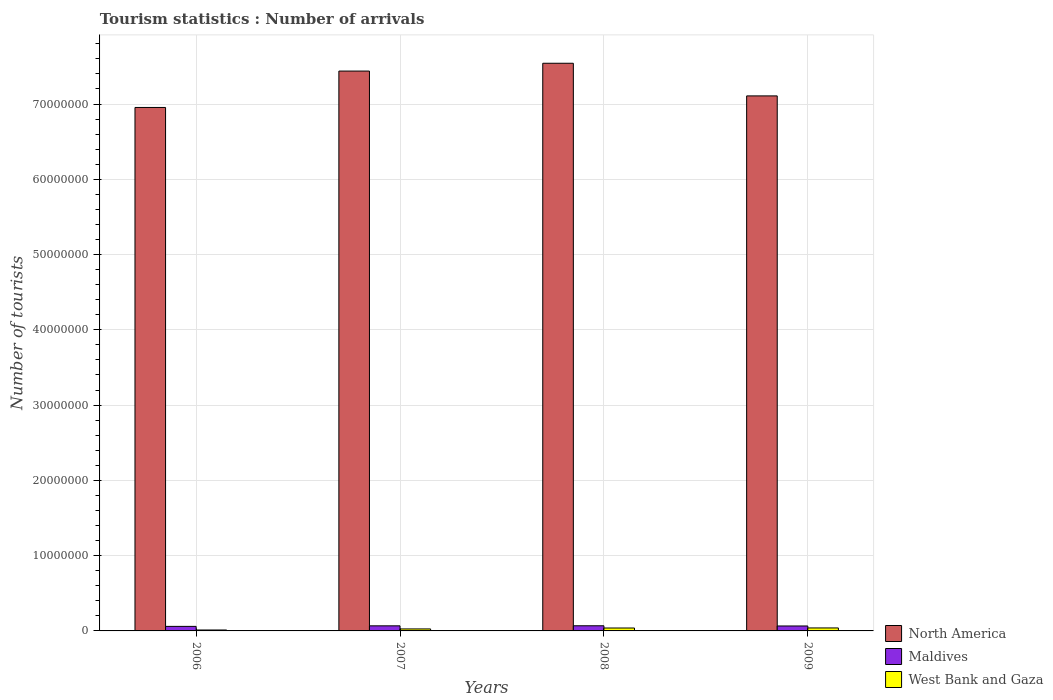How many different coloured bars are there?
Your answer should be compact. 3. How many groups of bars are there?
Provide a succinct answer. 4. Are the number of bars on each tick of the X-axis equal?
Offer a very short reply. Yes. How many bars are there on the 1st tick from the right?
Provide a short and direct response. 3. What is the label of the 3rd group of bars from the left?
Your response must be concise. 2008. What is the number of tourist arrivals in Maldives in 2008?
Provide a short and direct response. 6.83e+05. Across all years, what is the maximum number of tourist arrivals in Maldives?
Provide a succinct answer. 6.83e+05. Across all years, what is the minimum number of tourist arrivals in West Bank and Gaza?
Provide a short and direct response. 1.23e+05. In which year was the number of tourist arrivals in North America minimum?
Make the answer very short. 2006. What is the total number of tourist arrivals in West Bank and Gaza in the graph?
Your response must be concise. 1.17e+06. What is the difference between the number of tourist arrivals in Maldives in 2007 and that in 2008?
Provide a short and direct response. -7000. What is the difference between the number of tourist arrivals in North America in 2008 and the number of tourist arrivals in Maldives in 2009?
Your answer should be compact. 7.48e+07. What is the average number of tourist arrivals in Maldives per year?
Provide a short and direct response. 6.54e+05. In the year 2008, what is the difference between the number of tourist arrivals in Maldives and number of tourist arrivals in West Bank and Gaza?
Offer a terse response. 2.96e+05. What is the ratio of the number of tourist arrivals in North America in 2007 to that in 2009?
Offer a terse response. 1.05. What is the difference between the highest and the second highest number of tourist arrivals in Maldives?
Your response must be concise. 7000. What is the difference between the highest and the lowest number of tourist arrivals in West Bank and Gaza?
Make the answer very short. 2.73e+05. Is the sum of the number of tourist arrivals in West Bank and Gaza in 2006 and 2007 greater than the maximum number of tourist arrivals in North America across all years?
Provide a short and direct response. No. What does the 1st bar from the left in 2008 represents?
Provide a succinct answer. North America. What does the 2nd bar from the right in 2007 represents?
Offer a terse response. Maldives. How many bars are there?
Give a very brief answer. 12. Are all the bars in the graph horizontal?
Offer a terse response. No. How many years are there in the graph?
Offer a very short reply. 4. What is the difference between two consecutive major ticks on the Y-axis?
Provide a short and direct response. 1.00e+07. Where does the legend appear in the graph?
Provide a succinct answer. Bottom right. How many legend labels are there?
Ensure brevity in your answer.  3. What is the title of the graph?
Make the answer very short. Tourism statistics : Number of arrivals. What is the label or title of the X-axis?
Your response must be concise. Years. What is the label or title of the Y-axis?
Ensure brevity in your answer.  Number of tourists. What is the Number of tourists of North America in 2006?
Ensure brevity in your answer.  6.95e+07. What is the Number of tourists in Maldives in 2006?
Make the answer very short. 6.02e+05. What is the Number of tourists in West Bank and Gaza in 2006?
Keep it short and to the point. 1.23e+05. What is the Number of tourists of North America in 2007?
Provide a short and direct response. 7.44e+07. What is the Number of tourists in Maldives in 2007?
Your answer should be very brief. 6.76e+05. What is the Number of tourists of West Bank and Gaza in 2007?
Ensure brevity in your answer.  2.64e+05. What is the Number of tourists of North America in 2008?
Your response must be concise. 7.54e+07. What is the Number of tourists in Maldives in 2008?
Offer a terse response. 6.83e+05. What is the Number of tourists of West Bank and Gaza in 2008?
Give a very brief answer. 3.87e+05. What is the Number of tourists in North America in 2009?
Give a very brief answer. 7.11e+07. What is the Number of tourists in Maldives in 2009?
Your response must be concise. 6.56e+05. What is the Number of tourists in West Bank and Gaza in 2009?
Provide a short and direct response. 3.96e+05. Across all years, what is the maximum Number of tourists in North America?
Provide a short and direct response. 7.54e+07. Across all years, what is the maximum Number of tourists of Maldives?
Offer a very short reply. 6.83e+05. Across all years, what is the maximum Number of tourists in West Bank and Gaza?
Your answer should be compact. 3.96e+05. Across all years, what is the minimum Number of tourists of North America?
Provide a succinct answer. 6.95e+07. Across all years, what is the minimum Number of tourists of Maldives?
Keep it short and to the point. 6.02e+05. Across all years, what is the minimum Number of tourists in West Bank and Gaza?
Keep it short and to the point. 1.23e+05. What is the total Number of tourists of North America in the graph?
Keep it short and to the point. 2.90e+08. What is the total Number of tourists in Maldives in the graph?
Keep it short and to the point. 2.62e+06. What is the total Number of tourists of West Bank and Gaza in the graph?
Ensure brevity in your answer.  1.17e+06. What is the difference between the Number of tourists of North America in 2006 and that in 2007?
Provide a succinct answer. -4.84e+06. What is the difference between the Number of tourists of Maldives in 2006 and that in 2007?
Offer a very short reply. -7.40e+04. What is the difference between the Number of tourists of West Bank and Gaza in 2006 and that in 2007?
Make the answer very short. -1.41e+05. What is the difference between the Number of tourists of North America in 2006 and that in 2008?
Keep it short and to the point. -5.87e+06. What is the difference between the Number of tourists of Maldives in 2006 and that in 2008?
Keep it short and to the point. -8.10e+04. What is the difference between the Number of tourists of West Bank and Gaza in 2006 and that in 2008?
Ensure brevity in your answer.  -2.64e+05. What is the difference between the Number of tourists of North America in 2006 and that in 2009?
Offer a terse response. -1.54e+06. What is the difference between the Number of tourists in Maldives in 2006 and that in 2009?
Offer a terse response. -5.40e+04. What is the difference between the Number of tourists in West Bank and Gaza in 2006 and that in 2009?
Offer a very short reply. -2.73e+05. What is the difference between the Number of tourists in North America in 2007 and that in 2008?
Offer a terse response. -1.04e+06. What is the difference between the Number of tourists in Maldives in 2007 and that in 2008?
Your answer should be very brief. -7000. What is the difference between the Number of tourists of West Bank and Gaza in 2007 and that in 2008?
Keep it short and to the point. -1.23e+05. What is the difference between the Number of tourists of North America in 2007 and that in 2009?
Provide a succinct answer. 3.30e+06. What is the difference between the Number of tourists in Maldives in 2007 and that in 2009?
Keep it short and to the point. 2.00e+04. What is the difference between the Number of tourists of West Bank and Gaza in 2007 and that in 2009?
Keep it short and to the point. -1.32e+05. What is the difference between the Number of tourists of North America in 2008 and that in 2009?
Offer a very short reply. 4.34e+06. What is the difference between the Number of tourists of Maldives in 2008 and that in 2009?
Your response must be concise. 2.70e+04. What is the difference between the Number of tourists in West Bank and Gaza in 2008 and that in 2009?
Keep it short and to the point. -9000. What is the difference between the Number of tourists in North America in 2006 and the Number of tourists in Maldives in 2007?
Your answer should be compact. 6.89e+07. What is the difference between the Number of tourists of North America in 2006 and the Number of tourists of West Bank and Gaza in 2007?
Give a very brief answer. 6.93e+07. What is the difference between the Number of tourists in Maldives in 2006 and the Number of tourists in West Bank and Gaza in 2007?
Make the answer very short. 3.38e+05. What is the difference between the Number of tourists of North America in 2006 and the Number of tourists of Maldives in 2008?
Your response must be concise. 6.89e+07. What is the difference between the Number of tourists of North America in 2006 and the Number of tourists of West Bank and Gaza in 2008?
Provide a succinct answer. 6.92e+07. What is the difference between the Number of tourists in Maldives in 2006 and the Number of tourists in West Bank and Gaza in 2008?
Provide a succinct answer. 2.15e+05. What is the difference between the Number of tourists of North America in 2006 and the Number of tourists of Maldives in 2009?
Your answer should be compact. 6.89e+07. What is the difference between the Number of tourists of North America in 2006 and the Number of tourists of West Bank and Gaza in 2009?
Give a very brief answer. 6.91e+07. What is the difference between the Number of tourists in Maldives in 2006 and the Number of tourists in West Bank and Gaza in 2009?
Make the answer very short. 2.06e+05. What is the difference between the Number of tourists in North America in 2007 and the Number of tourists in Maldives in 2008?
Your response must be concise. 7.37e+07. What is the difference between the Number of tourists of North America in 2007 and the Number of tourists of West Bank and Gaza in 2008?
Provide a succinct answer. 7.40e+07. What is the difference between the Number of tourists in Maldives in 2007 and the Number of tourists in West Bank and Gaza in 2008?
Ensure brevity in your answer.  2.89e+05. What is the difference between the Number of tourists in North America in 2007 and the Number of tourists in Maldives in 2009?
Offer a very short reply. 7.37e+07. What is the difference between the Number of tourists in North America in 2007 and the Number of tourists in West Bank and Gaza in 2009?
Provide a succinct answer. 7.40e+07. What is the difference between the Number of tourists in Maldives in 2007 and the Number of tourists in West Bank and Gaza in 2009?
Make the answer very short. 2.80e+05. What is the difference between the Number of tourists in North America in 2008 and the Number of tourists in Maldives in 2009?
Offer a very short reply. 7.48e+07. What is the difference between the Number of tourists in North America in 2008 and the Number of tourists in West Bank and Gaza in 2009?
Keep it short and to the point. 7.50e+07. What is the difference between the Number of tourists in Maldives in 2008 and the Number of tourists in West Bank and Gaza in 2009?
Provide a succinct answer. 2.87e+05. What is the average Number of tourists of North America per year?
Offer a very short reply. 7.26e+07. What is the average Number of tourists of Maldives per year?
Your response must be concise. 6.54e+05. What is the average Number of tourists in West Bank and Gaza per year?
Your answer should be compact. 2.92e+05. In the year 2006, what is the difference between the Number of tourists in North America and Number of tourists in Maldives?
Offer a very short reply. 6.89e+07. In the year 2006, what is the difference between the Number of tourists in North America and Number of tourists in West Bank and Gaza?
Keep it short and to the point. 6.94e+07. In the year 2006, what is the difference between the Number of tourists in Maldives and Number of tourists in West Bank and Gaza?
Your answer should be very brief. 4.79e+05. In the year 2007, what is the difference between the Number of tourists of North America and Number of tourists of Maldives?
Provide a succinct answer. 7.37e+07. In the year 2007, what is the difference between the Number of tourists of North America and Number of tourists of West Bank and Gaza?
Your answer should be compact. 7.41e+07. In the year 2007, what is the difference between the Number of tourists in Maldives and Number of tourists in West Bank and Gaza?
Provide a short and direct response. 4.12e+05. In the year 2008, what is the difference between the Number of tourists in North America and Number of tourists in Maldives?
Give a very brief answer. 7.47e+07. In the year 2008, what is the difference between the Number of tourists of North America and Number of tourists of West Bank and Gaza?
Keep it short and to the point. 7.50e+07. In the year 2008, what is the difference between the Number of tourists in Maldives and Number of tourists in West Bank and Gaza?
Provide a succinct answer. 2.96e+05. In the year 2009, what is the difference between the Number of tourists of North America and Number of tourists of Maldives?
Keep it short and to the point. 7.04e+07. In the year 2009, what is the difference between the Number of tourists in North America and Number of tourists in West Bank and Gaza?
Keep it short and to the point. 7.07e+07. In the year 2009, what is the difference between the Number of tourists in Maldives and Number of tourists in West Bank and Gaza?
Make the answer very short. 2.60e+05. What is the ratio of the Number of tourists in North America in 2006 to that in 2007?
Your answer should be compact. 0.94. What is the ratio of the Number of tourists of Maldives in 2006 to that in 2007?
Offer a terse response. 0.89. What is the ratio of the Number of tourists of West Bank and Gaza in 2006 to that in 2007?
Your answer should be very brief. 0.47. What is the ratio of the Number of tourists of North America in 2006 to that in 2008?
Offer a terse response. 0.92. What is the ratio of the Number of tourists in Maldives in 2006 to that in 2008?
Give a very brief answer. 0.88. What is the ratio of the Number of tourists in West Bank and Gaza in 2006 to that in 2008?
Offer a terse response. 0.32. What is the ratio of the Number of tourists of North America in 2006 to that in 2009?
Make the answer very short. 0.98. What is the ratio of the Number of tourists in Maldives in 2006 to that in 2009?
Provide a short and direct response. 0.92. What is the ratio of the Number of tourists in West Bank and Gaza in 2006 to that in 2009?
Your answer should be very brief. 0.31. What is the ratio of the Number of tourists in North America in 2007 to that in 2008?
Your answer should be compact. 0.99. What is the ratio of the Number of tourists in Maldives in 2007 to that in 2008?
Provide a succinct answer. 0.99. What is the ratio of the Number of tourists of West Bank and Gaza in 2007 to that in 2008?
Your answer should be very brief. 0.68. What is the ratio of the Number of tourists in North America in 2007 to that in 2009?
Make the answer very short. 1.05. What is the ratio of the Number of tourists in Maldives in 2007 to that in 2009?
Provide a succinct answer. 1.03. What is the ratio of the Number of tourists of North America in 2008 to that in 2009?
Give a very brief answer. 1.06. What is the ratio of the Number of tourists of Maldives in 2008 to that in 2009?
Your answer should be compact. 1.04. What is the ratio of the Number of tourists in West Bank and Gaza in 2008 to that in 2009?
Give a very brief answer. 0.98. What is the difference between the highest and the second highest Number of tourists in North America?
Your answer should be compact. 1.04e+06. What is the difference between the highest and the second highest Number of tourists of Maldives?
Make the answer very short. 7000. What is the difference between the highest and the second highest Number of tourists in West Bank and Gaza?
Provide a succinct answer. 9000. What is the difference between the highest and the lowest Number of tourists in North America?
Keep it short and to the point. 5.87e+06. What is the difference between the highest and the lowest Number of tourists in Maldives?
Your answer should be very brief. 8.10e+04. What is the difference between the highest and the lowest Number of tourists in West Bank and Gaza?
Your answer should be very brief. 2.73e+05. 